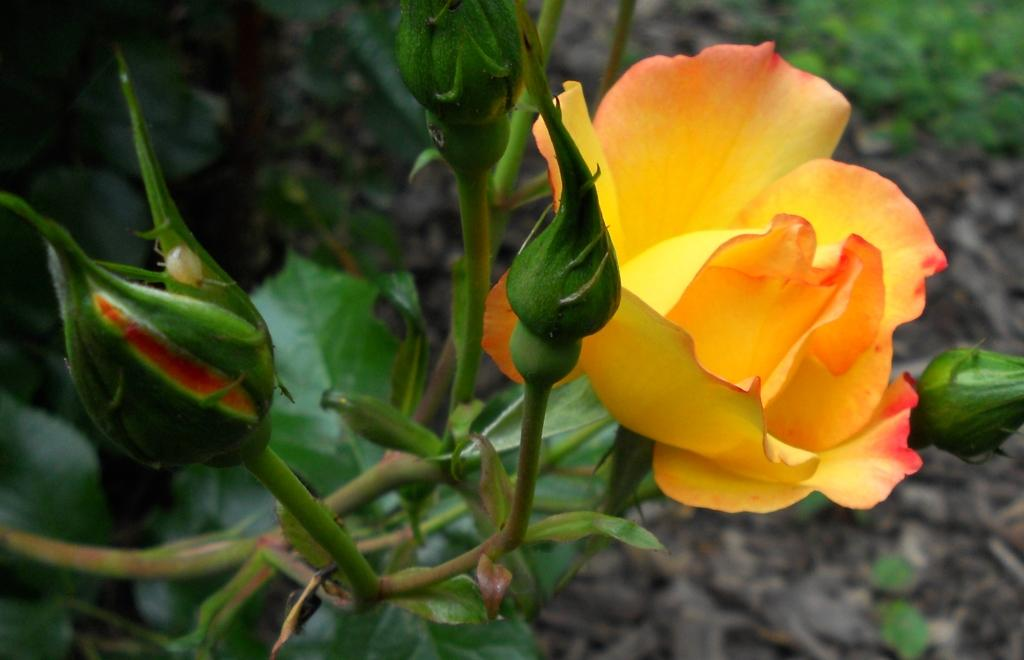What type of flower is on the right side of the image? There is a rose on the right side of the image. What is the stage of the flower on the left side of the image? There is a bud on the left side of the image. What can be seen in the background of the image? There is greenery in the background of the image. What type of beef is being served on the table in the image? There is no beef present in the image; it features a rose, a bud, and greenery. What advice can be given to the rose in the image? The image does not depict a situation where advice can be given to the rose, as it is a still image of a rose and a bud. 